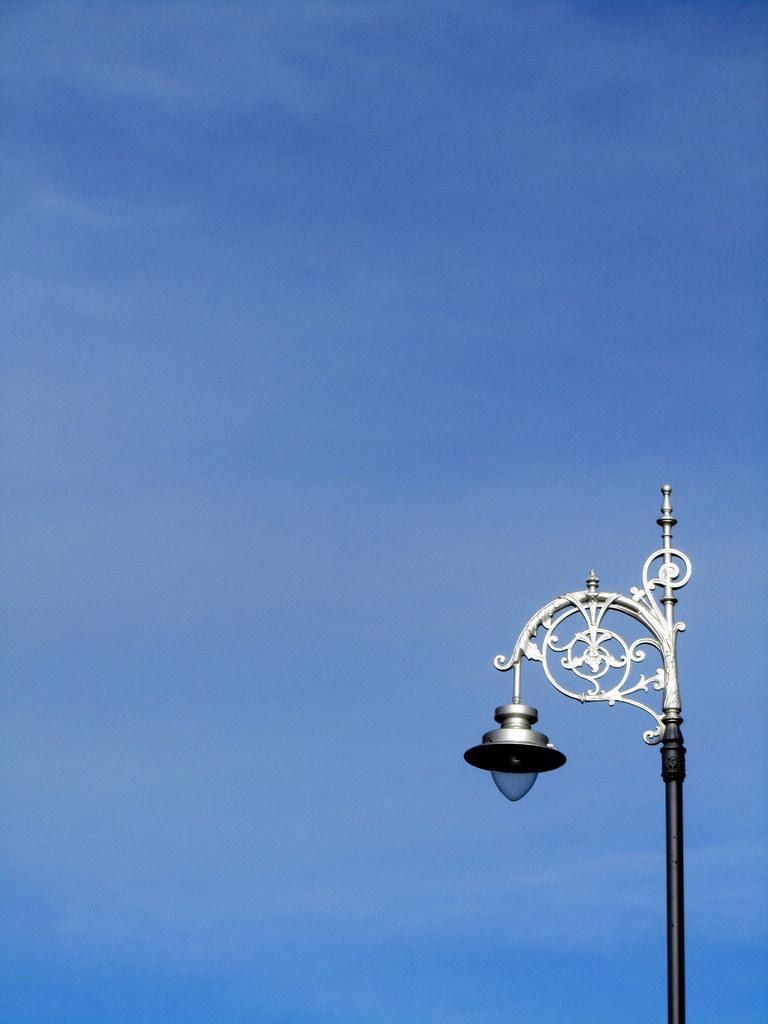Could you give a brief overview of what you see in this image? In this image we can see a light, and a pole, also we can see the sky 